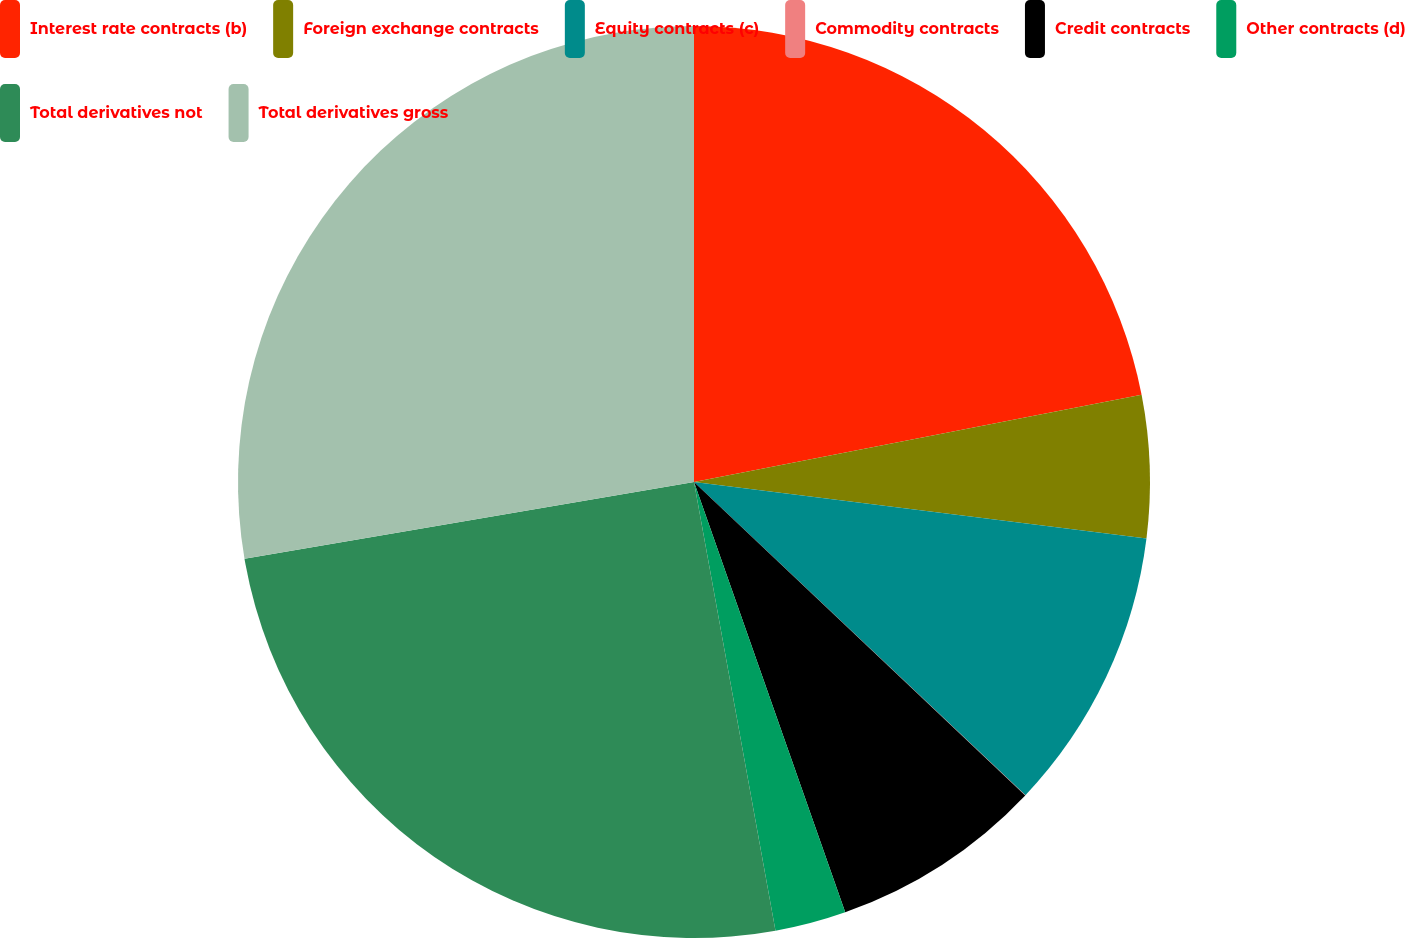Convert chart. <chart><loc_0><loc_0><loc_500><loc_500><pie_chart><fcel>Interest rate contracts (b)<fcel>Foreign exchange contracts<fcel>Equity contracts (c)<fcel>Commodity contracts<fcel>Credit contracts<fcel>Other contracts (d)<fcel>Total derivatives not<fcel>Total derivatives gross<nl><fcel>21.94%<fcel>5.04%<fcel>10.07%<fcel>0.01%<fcel>7.56%<fcel>2.52%<fcel>25.17%<fcel>27.69%<nl></chart> 